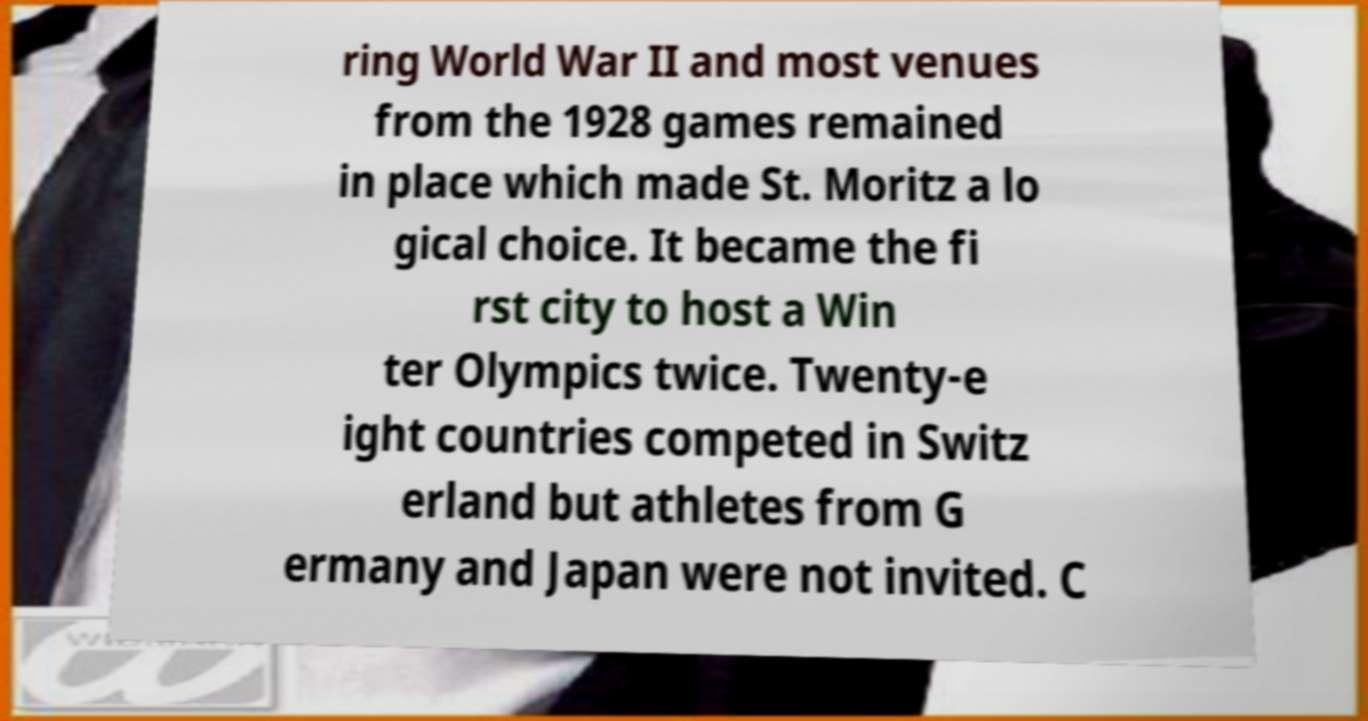There's text embedded in this image that I need extracted. Can you transcribe it verbatim? ring World War II and most venues from the 1928 games remained in place which made St. Moritz a lo gical choice. It became the fi rst city to host a Win ter Olympics twice. Twenty-e ight countries competed in Switz erland but athletes from G ermany and Japan were not invited. C 